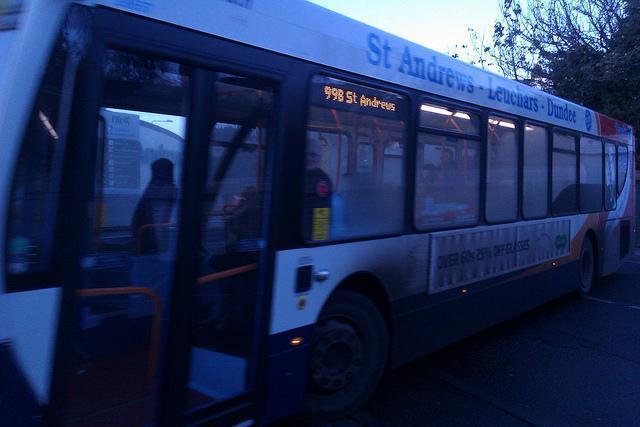How many decks does the bus in the front have?
Give a very brief answer. 1. 